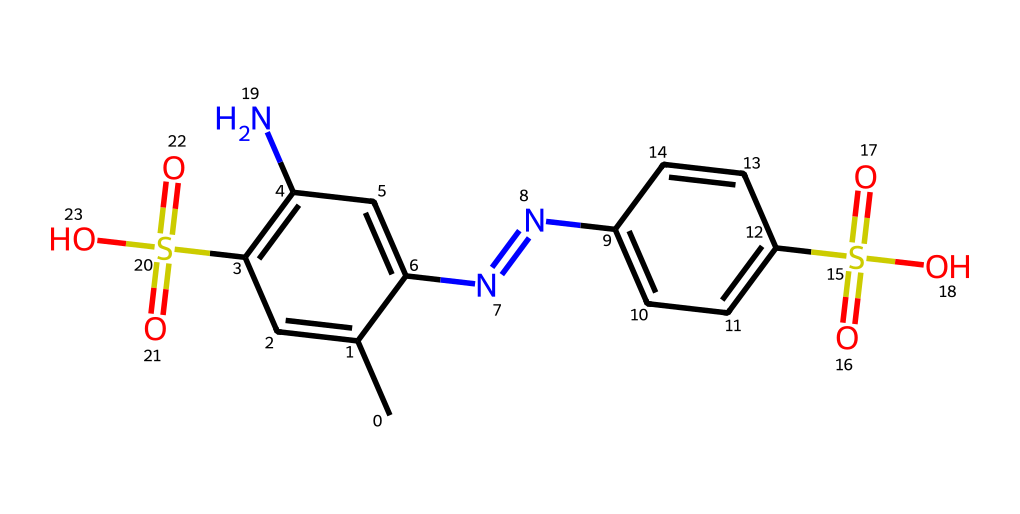What is the main functional group present in this chemical? The chemical contains sulfonic acid groups indicated by the presence of -S(=O)(=O)O. This suggests the presence of the sulfonic functional group which is responsible for many properties, including solubility and reactivity.
Answer: sulfonic acid How many nitrogen atoms are present in the structure? By examining the SMILES notation, there are two occurrences of 'N', indicating the presence of two nitrogen atoms in the chemical structure.
Answer: 2 What is the total number of carbon atoms in this compound? The formula has five occurrences of 'C' in its structure, each representing a carbon atom. Therefore, the total number of carbon atoms can be counted directly from the notation.
Answer: 12 What type of chemical is this according to its usage in game boards? This chemical is classified as an artificial dye due to its vibrant color properties which are utilized for coloring materials, such as game boards.
Answer: artificial dye Does this compound contain any aromatic rings? The presence of multiple 'C=C' bonds indicates that there are several aromatic rings in the structure typical of azo dyes. The cyclical arrangement of carbon atoms in certain segments of the structure indicates they are aromatic.
Answer: yes What is the overall charge of the sulfonic acid groups in this compound? Sulfonic acid groups (−SO3H) carry a negative charge when dissociated, thus indicating they impart a net negative charge to the overall compound when accounting for dissociation at neutral pH conditions.
Answer: negative 